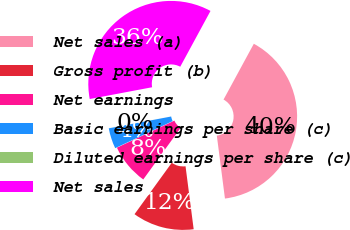<chart> <loc_0><loc_0><loc_500><loc_500><pie_chart><fcel>Net sales (a)<fcel>Gross profit (b)<fcel>Net earnings<fcel>Basic earnings per share (c)<fcel>Diluted earnings per share (c)<fcel>Net sales<nl><fcel>40.04%<fcel>12.02%<fcel>8.02%<fcel>4.02%<fcel>0.01%<fcel>35.88%<nl></chart> 